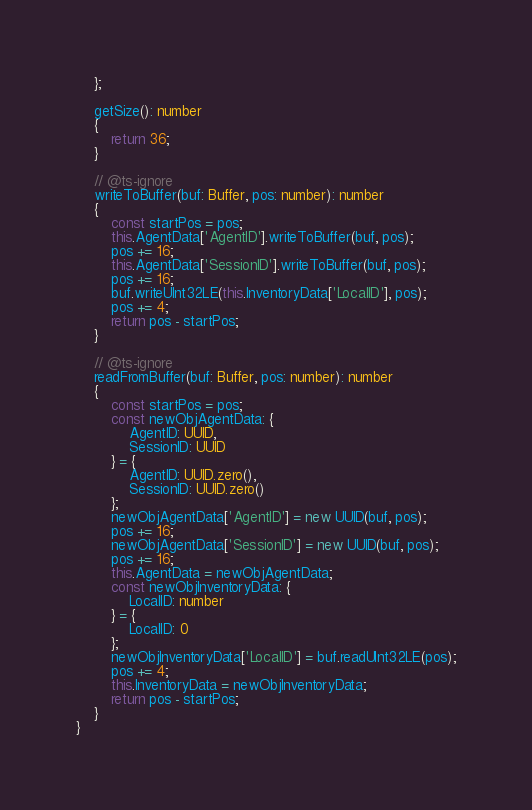<code> <loc_0><loc_0><loc_500><loc_500><_TypeScript_>    };

    getSize(): number
    {
        return 36;
    }

    // @ts-ignore
    writeToBuffer(buf: Buffer, pos: number): number
    {
        const startPos = pos;
        this.AgentData['AgentID'].writeToBuffer(buf, pos);
        pos += 16;
        this.AgentData['SessionID'].writeToBuffer(buf, pos);
        pos += 16;
        buf.writeUInt32LE(this.InventoryData['LocalID'], pos);
        pos += 4;
        return pos - startPos;
    }

    // @ts-ignore
    readFromBuffer(buf: Buffer, pos: number): number
    {
        const startPos = pos;
        const newObjAgentData: {
            AgentID: UUID,
            SessionID: UUID
        } = {
            AgentID: UUID.zero(),
            SessionID: UUID.zero()
        };
        newObjAgentData['AgentID'] = new UUID(buf, pos);
        pos += 16;
        newObjAgentData['SessionID'] = new UUID(buf, pos);
        pos += 16;
        this.AgentData = newObjAgentData;
        const newObjInventoryData: {
            LocalID: number
        } = {
            LocalID: 0
        };
        newObjInventoryData['LocalID'] = buf.readUInt32LE(pos);
        pos += 4;
        this.InventoryData = newObjInventoryData;
        return pos - startPos;
    }
}

</code> 